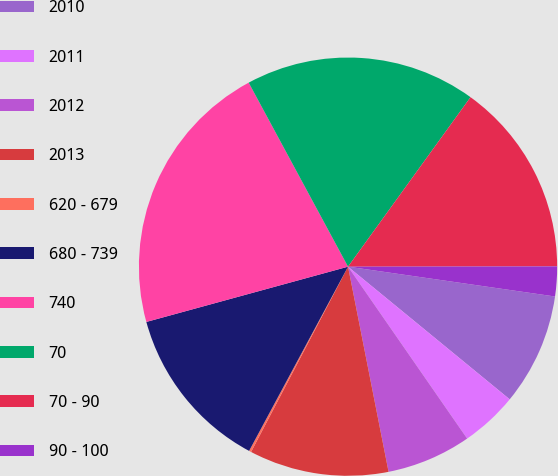<chart> <loc_0><loc_0><loc_500><loc_500><pie_chart><fcel>2010<fcel>2011<fcel>2012<fcel>2013<fcel>620 - 679<fcel>680 - 739<fcel>740<fcel>70<fcel>70 - 90<fcel>90 - 100<nl><fcel>8.66%<fcel>4.42%<fcel>6.54%<fcel>10.78%<fcel>0.17%<fcel>12.9%<fcel>21.38%<fcel>17.84%<fcel>15.02%<fcel>2.3%<nl></chart> 